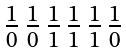Convert formula to latex. <formula><loc_0><loc_0><loc_500><loc_500>\begin{smallmatrix} 1 & 1 & 1 & 1 & 1 & 1 \\ \overline { 0 } & \overline { 0 } & \overline { 1 } & \overline { 1 } & \overline { 1 } & \overline { 0 } \\ \end{smallmatrix}</formula> 